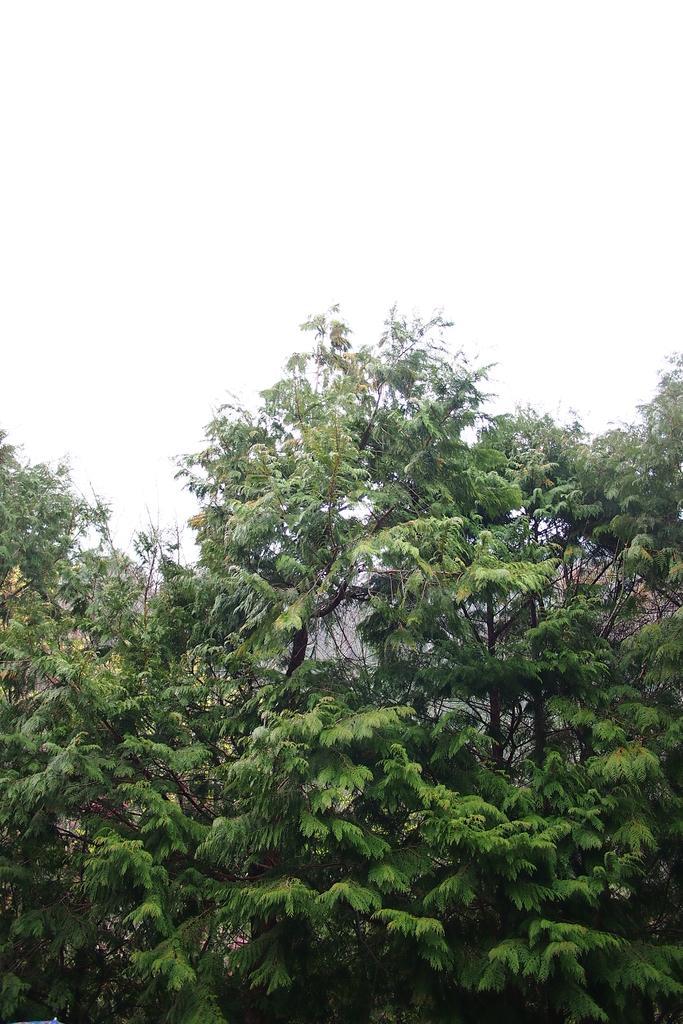Can you describe this image briefly? Here we can see green trees. Background it is white. 